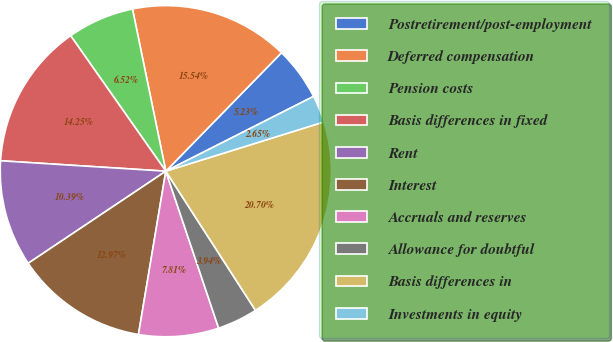Convert chart to OTSL. <chart><loc_0><loc_0><loc_500><loc_500><pie_chart><fcel>Postretirement/post-employment<fcel>Deferred compensation<fcel>Pension costs<fcel>Basis differences in fixed<fcel>Rent<fcel>Interest<fcel>Accruals and reserves<fcel>Allowance for doubtful<fcel>Basis differences in<fcel>Investments in equity<nl><fcel>5.23%<fcel>15.54%<fcel>6.52%<fcel>14.25%<fcel>10.39%<fcel>12.97%<fcel>7.81%<fcel>3.94%<fcel>20.7%<fcel>2.65%<nl></chart> 